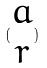<formula> <loc_0><loc_0><loc_500><loc_500>( \begin{matrix} a \\ r \end{matrix} )</formula> 